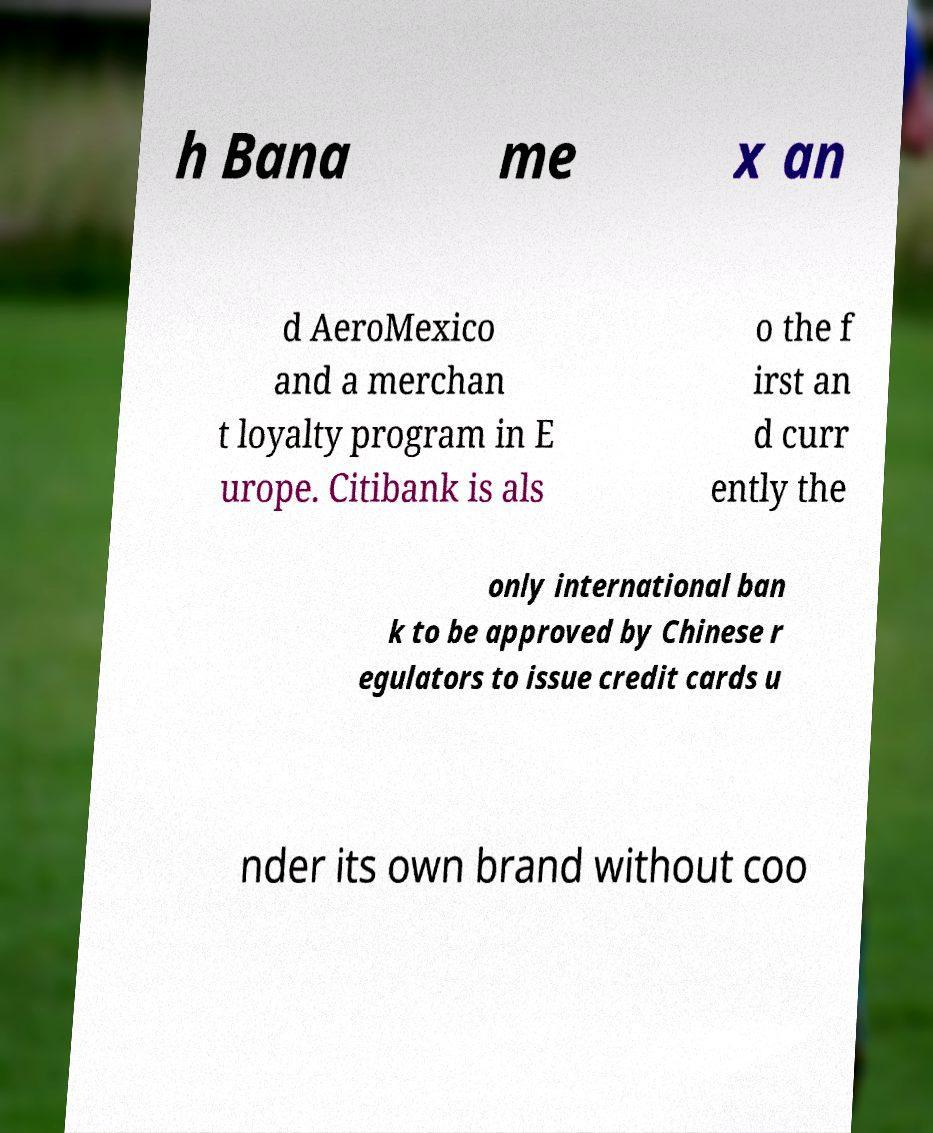Can you accurately transcribe the text from the provided image for me? h Bana me x an d AeroMexico and a merchan t loyalty program in E urope. Citibank is als o the f irst an d curr ently the only international ban k to be approved by Chinese r egulators to issue credit cards u nder its own brand without coo 